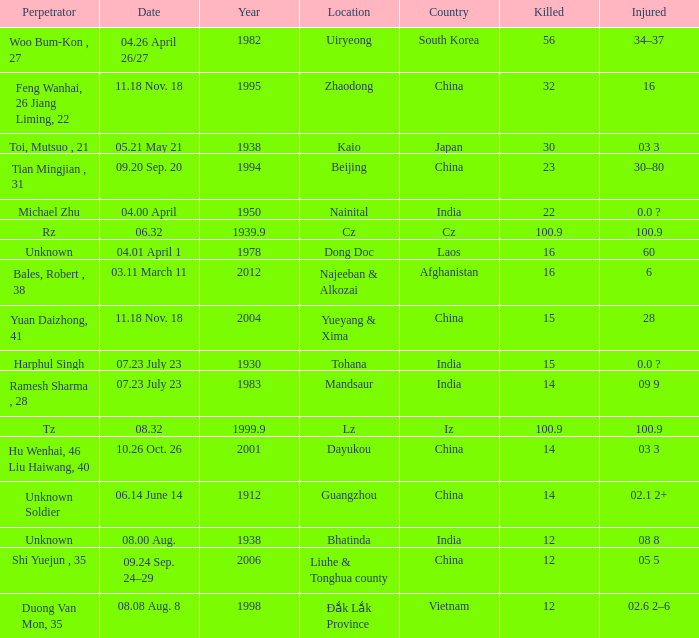9? Iz. 